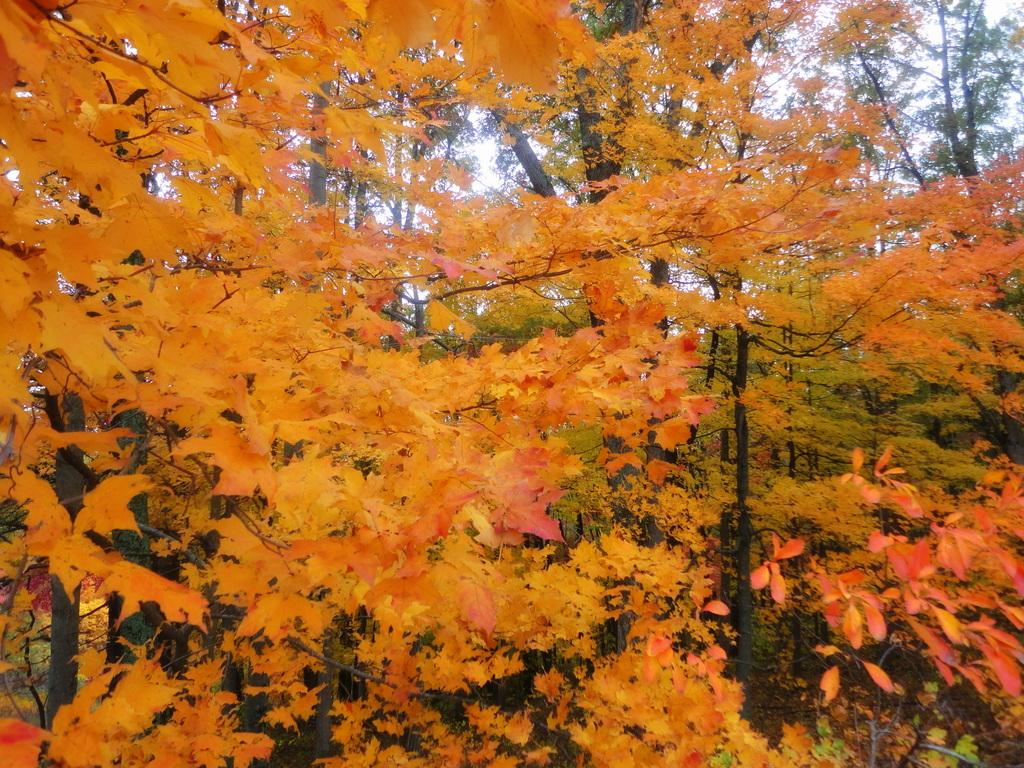What type of trees are present in the image? There are trees with maple leaves in the image. What colors are the maple leaves? The maple leaves are yellow and orange in color. What else can be seen in the background of the image? There are other trees visible in the background of the image. What part of the natural environment is visible in the image? A part of the sky is visible in the image. What type of territory is being claimed by the fairies in the image? There are no fairies present in the image, so no territory is being claimed. Can you describe the locket that the maple leaves are hanging from in the image? There is no locket present in the image; the maple leaves are attached to the trees. 